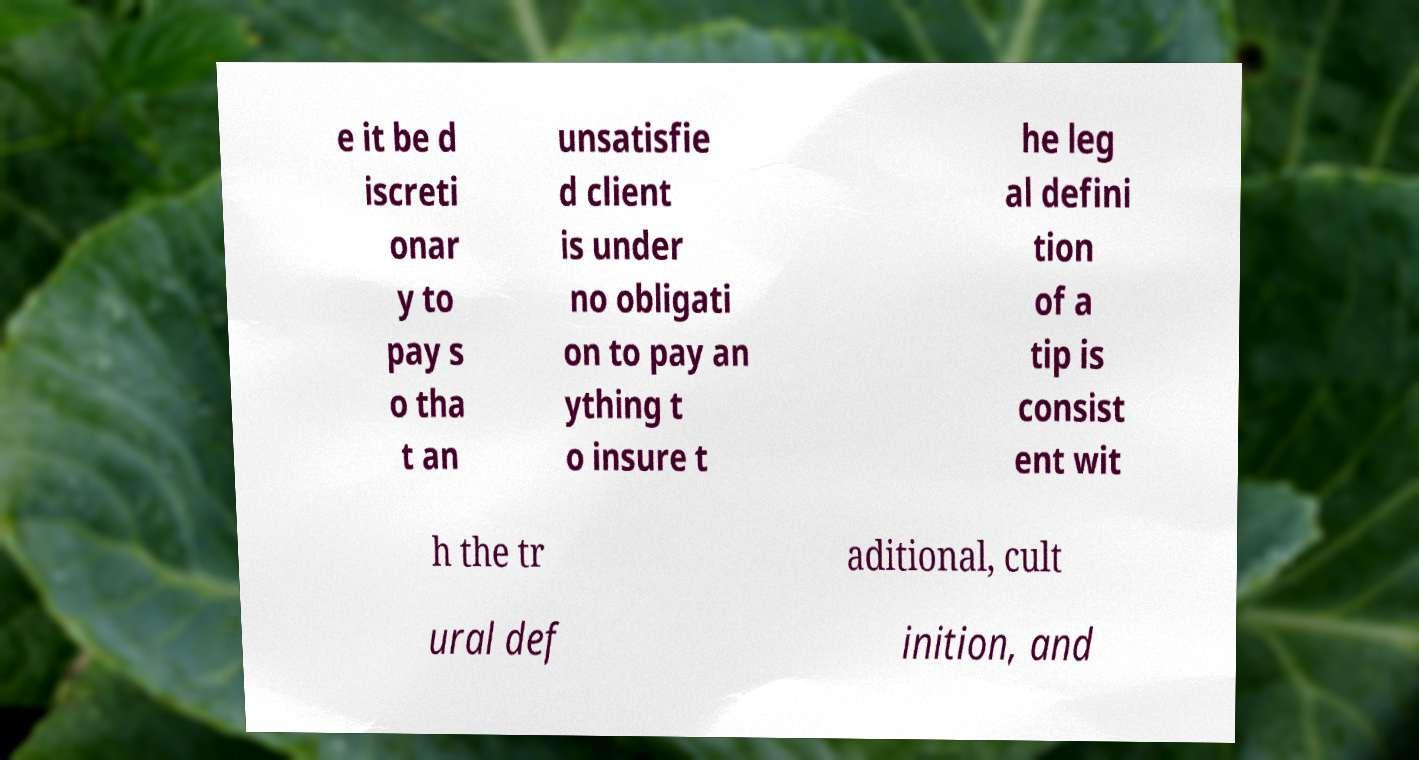Could you assist in decoding the text presented in this image and type it out clearly? e it be d iscreti onar y to pay s o tha t an unsatisfie d client is under no obligati on to pay an ything t o insure t he leg al defini tion of a tip is consist ent wit h the tr aditional, cult ural def inition, and 